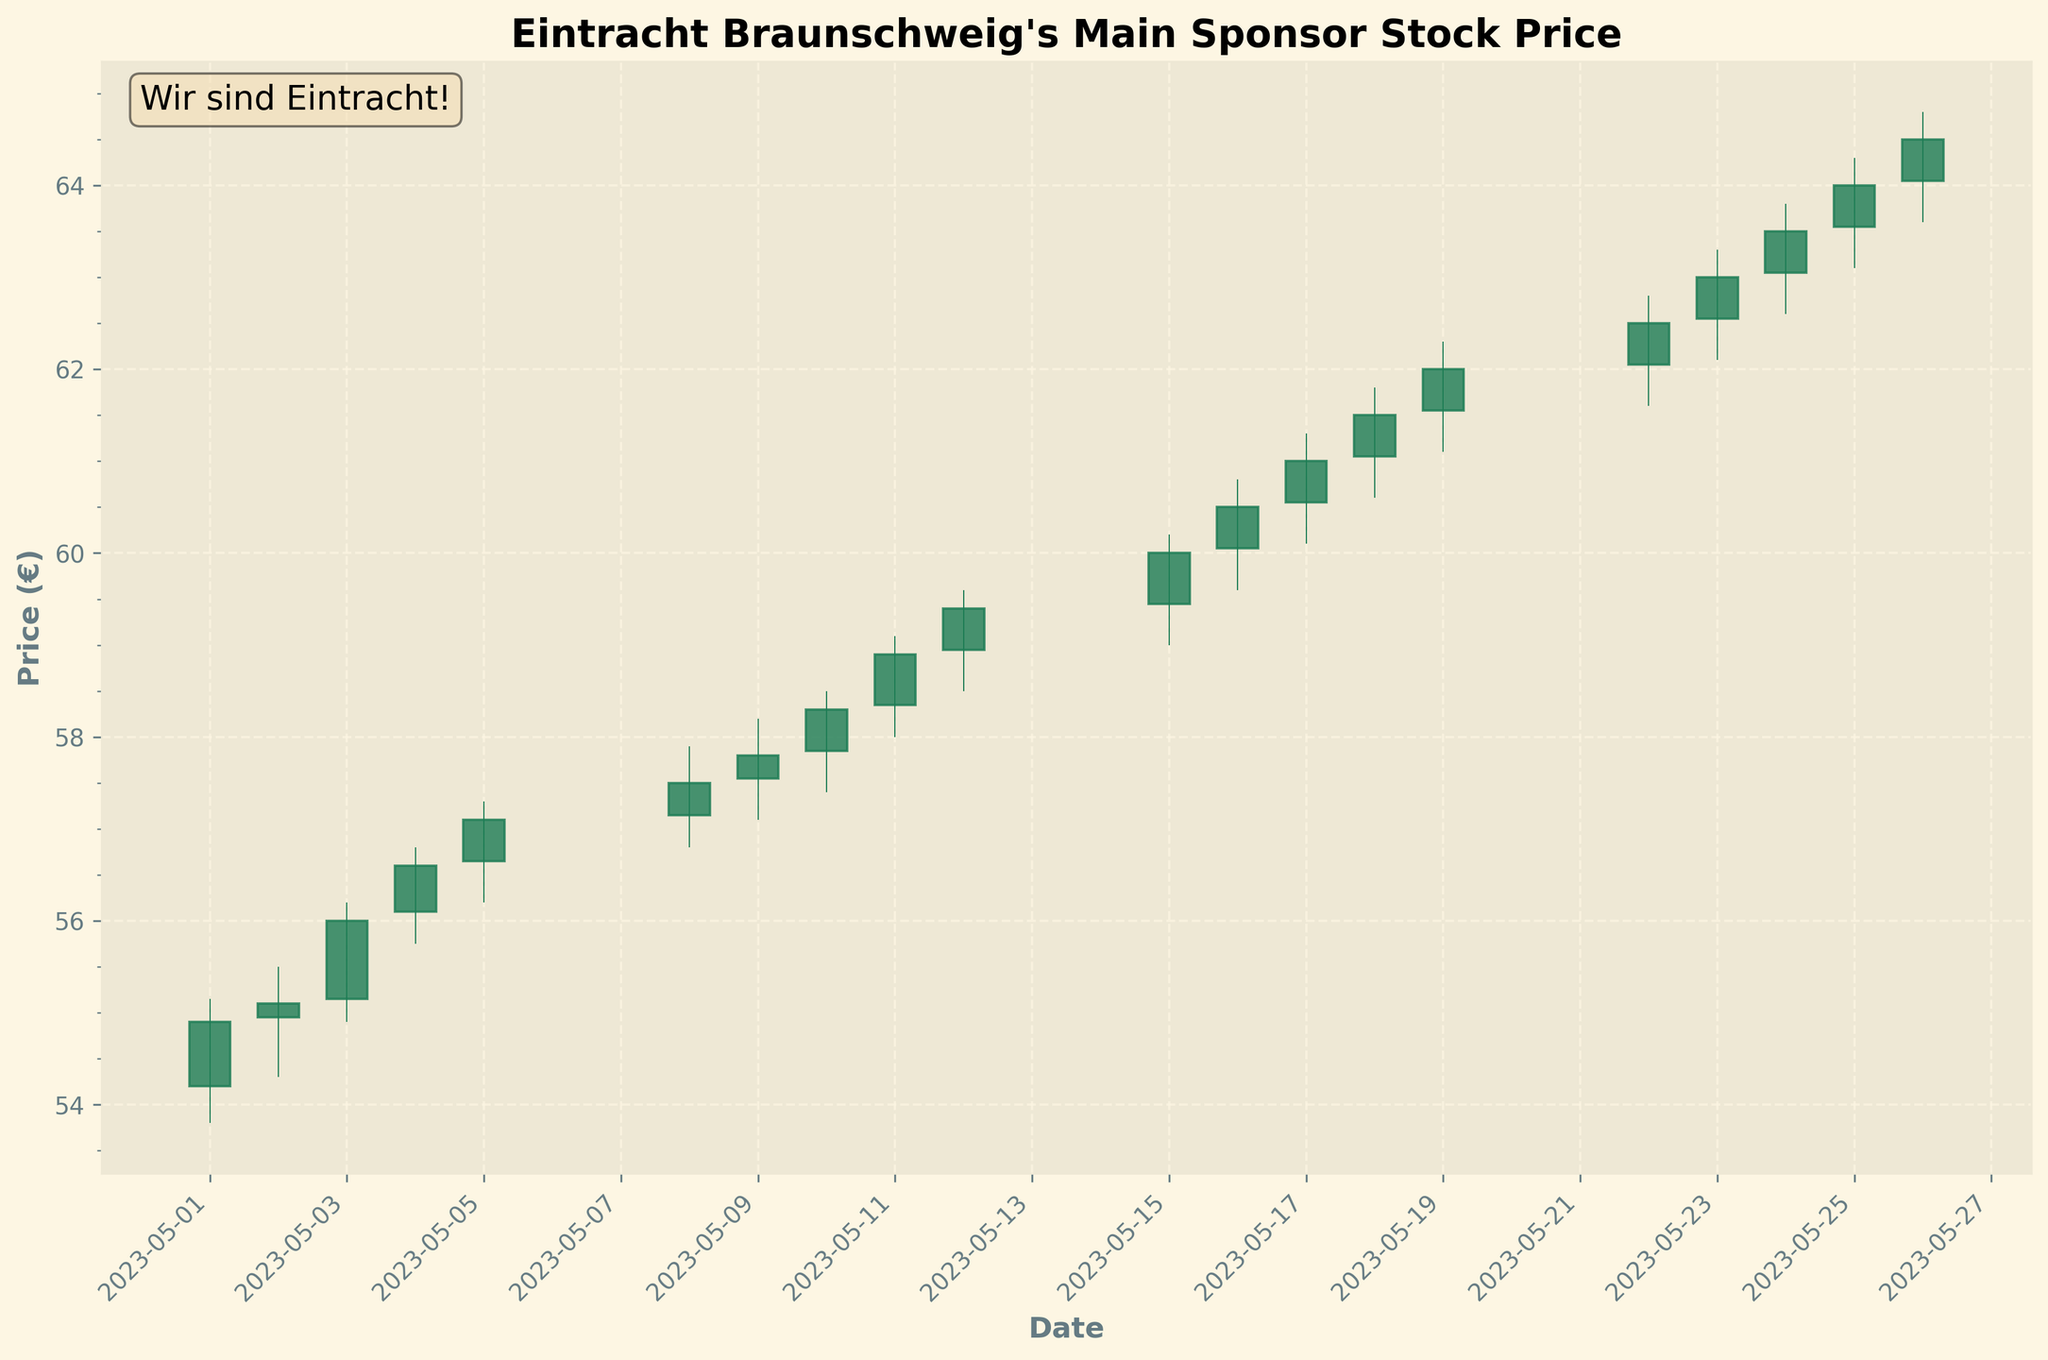What's the title of the figure? The title of the figure is located at the top of the chart. By reading it, you can understand what the chart is about.
Answer: Eintracht Braunschweig's Main Sponsor Stock Price How many data points are shown in the figure? Each vertical bar (or candlestick) in the chart represents a data point corresponding to a day's stock prices. By counting them, you can find the number of data points.
Answer: 20 Which date had the highest closing price in the chart? To determine this, locate the candlestick with the highest point in the "Close" position, then match it to the corresponding date on the x-axis.
Answer: 2023-05-26 What was the price range on the 2023-05-15? The price range for a single day is given by the difference between the highest and lowest prices for that day. This information can be found on the candlestick for 2023-05-15.
Answer: 1.20 (60.20 - 59.00) On which date did the stock make the largest single-day gain from open to close? To find the largest single-day gain, calculate the difference between the "Close" and "Open" prices for each day, then identify the date with the maximum positive difference.
Answer: 2023-05-15 (0.55) Which date had both the lowest opening and closing price? Look for the lowest points among the "Open" and "Close" prices. If they occur on the same candlestick, identify the corresponding date.
Answer: 2023-05-01 What was the average closing price during the first week (May 1-May 5)? Calculate the sum of the closing prices from May 1 to May 5 and divide it by the number of days (5) to get the average.
Answer: 55.94 ((54.90 + 55.10 + 56.00 + 56.60 + 57.10) / 5) How did the closing price on the last day (May 26) compare to the opening price on the first day (May 1)? Compare the closing price on May 26 with the opening price on May 1 to determine the difference or percentage change.
Answer: Higher (64.50 compared to 54.20) Which date had the largest intraday range (difference between high and low) and what was this value? Find the candlestick with the widest range between its top and bottom. The intraday range is the difference between the highest and lowest prices.
Answer: 2023-05-24 (1.20) What was the trend of the stock price over the month? Observe the general direction of the closing prices over the entire period to determine whether they are increasing, decreasing, or stable.
Answer: Upward 